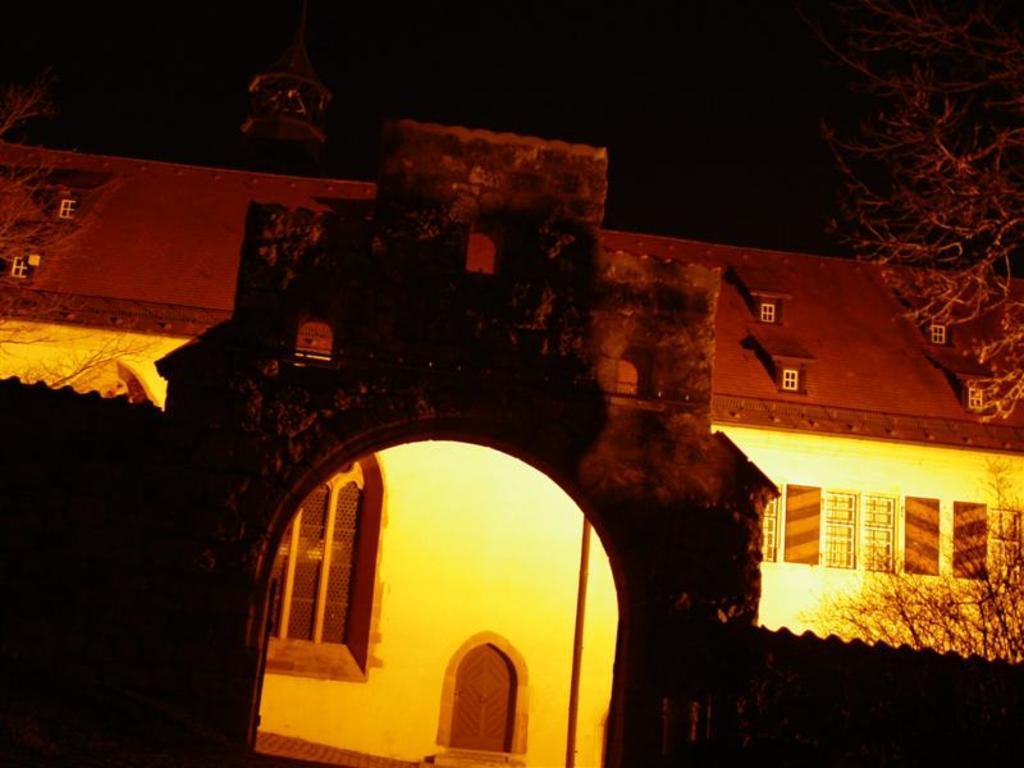Please provide a concise description of this image. In this picture we can see an arch, walls, house and trees. In the background of the image it is dark. 